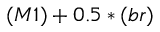<formula> <loc_0><loc_0><loc_500><loc_500>( M 1 ) + 0 . 5 * ( b r )</formula> 